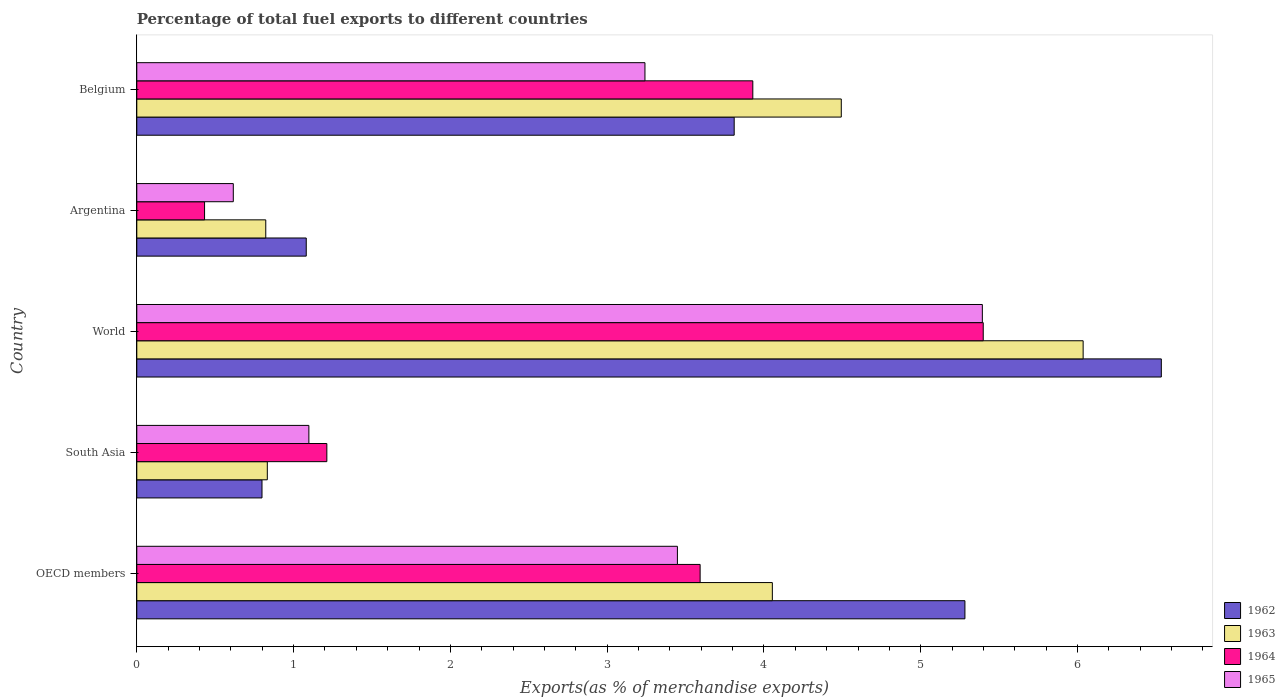Are the number of bars on each tick of the Y-axis equal?
Provide a succinct answer. Yes. How many bars are there on the 4th tick from the top?
Make the answer very short. 4. What is the label of the 2nd group of bars from the top?
Keep it short and to the point. Argentina. What is the percentage of exports to different countries in 1964 in Argentina?
Provide a short and direct response. 0.43. Across all countries, what is the maximum percentage of exports to different countries in 1962?
Your answer should be very brief. 6.53. Across all countries, what is the minimum percentage of exports to different countries in 1964?
Provide a succinct answer. 0.43. In which country was the percentage of exports to different countries in 1962 minimum?
Your response must be concise. South Asia. What is the total percentage of exports to different countries in 1964 in the graph?
Offer a terse response. 14.57. What is the difference between the percentage of exports to different countries in 1962 in Belgium and that in OECD members?
Provide a succinct answer. -1.47. What is the difference between the percentage of exports to different countries in 1964 in OECD members and the percentage of exports to different countries in 1965 in Argentina?
Offer a terse response. 2.98. What is the average percentage of exports to different countries in 1963 per country?
Give a very brief answer. 3.25. What is the difference between the percentage of exports to different countries in 1963 and percentage of exports to different countries in 1965 in Belgium?
Your answer should be compact. 1.25. What is the ratio of the percentage of exports to different countries in 1964 in Belgium to that in OECD members?
Your answer should be very brief. 1.09. Is the percentage of exports to different countries in 1963 in Belgium less than that in South Asia?
Your answer should be compact. No. What is the difference between the highest and the second highest percentage of exports to different countries in 1963?
Your answer should be very brief. 1.54. What is the difference between the highest and the lowest percentage of exports to different countries in 1962?
Offer a very short reply. 5.74. Is it the case that in every country, the sum of the percentage of exports to different countries in 1965 and percentage of exports to different countries in 1963 is greater than the sum of percentage of exports to different countries in 1964 and percentage of exports to different countries in 1962?
Offer a very short reply. No. What does the 2nd bar from the top in Argentina represents?
Ensure brevity in your answer.  1964. Are all the bars in the graph horizontal?
Offer a very short reply. Yes. Are the values on the major ticks of X-axis written in scientific E-notation?
Provide a short and direct response. No. Does the graph contain any zero values?
Your response must be concise. No. Does the graph contain grids?
Your answer should be compact. No. Where does the legend appear in the graph?
Give a very brief answer. Bottom right. How many legend labels are there?
Provide a short and direct response. 4. What is the title of the graph?
Your response must be concise. Percentage of total fuel exports to different countries. Does "1968" appear as one of the legend labels in the graph?
Offer a very short reply. No. What is the label or title of the X-axis?
Your response must be concise. Exports(as % of merchandise exports). What is the label or title of the Y-axis?
Offer a very short reply. Country. What is the Exports(as % of merchandise exports) of 1962 in OECD members?
Your answer should be very brief. 5.28. What is the Exports(as % of merchandise exports) of 1963 in OECD members?
Offer a terse response. 4.05. What is the Exports(as % of merchandise exports) in 1964 in OECD members?
Make the answer very short. 3.59. What is the Exports(as % of merchandise exports) in 1965 in OECD members?
Provide a succinct answer. 3.45. What is the Exports(as % of merchandise exports) in 1962 in South Asia?
Offer a very short reply. 0.8. What is the Exports(as % of merchandise exports) in 1963 in South Asia?
Make the answer very short. 0.83. What is the Exports(as % of merchandise exports) of 1964 in South Asia?
Make the answer very short. 1.21. What is the Exports(as % of merchandise exports) of 1965 in South Asia?
Your answer should be compact. 1.1. What is the Exports(as % of merchandise exports) of 1962 in World?
Offer a terse response. 6.53. What is the Exports(as % of merchandise exports) of 1963 in World?
Your answer should be very brief. 6.04. What is the Exports(as % of merchandise exports) of 1964 in World?
Your response must be concise. 5.4. What is the Exports(as % of merchandise exports) in 1965 in World?
Offer a very short reply. 5.39. What is the Exports(as % of merchandise exports) of 1962 in Argentina?
Provide a short and direct response. 1.08. What is the Exports(as % of merchandise exports) of 1963 in Argentina?
Provide a short and direct response. 0.82. What is the Exports(as % of merchandise exports) in 1964 in Argentina?
Ensure brevity in your answer.  0.43. What is the Exports(as % of merchandise exports) of 1965 in Argentina?
Offer a very short reply. 0.62. What is the Exports(as % of merchandise exports) of 1962 in Belgium?
Provide a short and direct response. 3.81. What is the Exports(as % of merchandise exports) of 1963 in Belgium?
Offer a terse response. 4.49. What is the Exports(as % of merchandise exports) in 1964 in Belgium?
Your answer should be very brief. 3.93. What is the Exports(as % of merchandise exports) of 1965 in Belgium?
Provide a succinct answer. 3.24. Across all countries, what is the maximum Exports(as % of merchandise exports) of 1962?
Ensure brevity in your answer.  6.53. Across all countries, what is the maximum Exports(as % of merchandise exports) of 1963?
Give a very brief answer. 6.04. Across all countries, what is the maximum Exports(as % of merchandise exports) of 1964?
Your answer should be compact. 5.4. Across all countries, what is the maximum Exports(as % of merchandise exports) of 1965?
Make the answer very short. 5.39. Across all countries, what is the minimum Exports(as % of merchandise exports) of 1962?
Make the answer very short. 0.8. Across all countries, what is the minimum Exports(as % of merchandise exports) in 1963?
Make the answer very short. 0.82. Across all countries, what is the minimum Exports(as % of merchandise exports) in 1964?
Make the answer very short. 0.43. Across all countries, what is the minimum Exports(as % of merchandise exports) of 1965?
Your answer should be very brief. 0.62. What is the total Exports(as % of merchandise exports) of 1962 in the graph?
Offer a very short reply. 17.51. What is the total Exports(as % of merchandise exports) in 1963 in the graph?
Keep it short and to the point. 16.24. What is the total Exports(as % of merchandise exports) of 1964 in the graph?
Offer a terse response. 14.57. What is the total Exports(as % of merchandise exports) of 1965 in the graph?
Keep it short and to the point. 13.8. What is the difference between the Exports(as % of merchandise exports) of 1962 in OECD members and that in South Asia?
Keep it short and to the point. 4.48. What is the difference between the Exports(as % of merchandise exports) in 1963 in OECD members and that in South Asia?
Provide a short and direct response. 3.22. What is the difference between the Exports(as % of merchandise exports) of 1964 in OECD members and that in South Asia?
Make the answer very short. 2.38. What is the difference between the Exports(as % of merchandise exports) in 1965 in OECD members and that in South Asia?
Offer a terse response. 2.35. What is the difference between the Exports(as % of merchandise exports) in 1962 in OECD members and that in World?
Provide a short and direct response. -1.25. What is the difference between the Exports(as % of merchandise exports) of 1963 in OECD members and that in World?
Your answer should be compact. -1.98. What is the difference between the Exports(as % of merchandise exports) in 1964 in OECD members and that in World?
Ensure brevity in your answer.  -1.81. What is the difference between the Exports(as % of merchandise exports) of 1965 in OECD members and that in World?
Provide a short and direct response. -1.94. What is the difference between the Exports(as % of merchandise exports) in 1962 in OECD members and that in Argentina?
Offer a terse response. 4.2. What is the difference between the Exports(as % of merchandise exports) of 1963 in OECD members and that in Argentina?
Offer a very short reply. 3.23. What is the difference between the Exports(as % of merchandise exports) of 1964 in OECD members and that in Argentina?
Make the answer very short. 3.16. What is the difference between the Exports(as % of merchandise exports) of 1965 in OECD members and that in Argentina?
Keep it short and to the point. 2.83. What is the difference between the Exports(as % of merchandise exports) in 1962 in OECD members and that in Belgium?
Keep it short and to the point. 1.47. What is the difference between the Exports(as % of merchandise exports) in 1963 in OECD members and that in Belgium?
Give a very brief answer. -0.44. What is the difference between the Exports(as % of merchandise exports) of 1964 in OECD members and that in Belgium?
Provide a succinct answer. -0.34. What is the difference between the Exports(as % of merchandise exports) of 1965 in OECD members and that in Belgium?
Offer a terse response. 0.21. What is the difference between the Exports(as % of merchandise exports) in 1962 in South Asia and that in World?
Provide a succinct answer. -5.74. What is the difference between the Exports(as % of merchandise exports) of 1963 in South Asia and that in World?
Provide a succinct answer. -5.2. What is the difference between the Exports(as % of merchandise exports) in 1964 in South Asia and that in World?
Provide a short and direct response. -4.19. What is the difference between the Exports(as % of merchandise exports) in 1965 in South Asia and that in World?
Your response must be concise. -4.3. What is the difference between the Exports(as % of merchandise exports) of 1962 in South Asia and that in Argentina?
Give a very brief answer. -0.28. What is the difference between the Exports(as % of merchandise exports) in 1963 in South Asia and that in Argentina?
Make the answer very short. 0.01. What is the difference between the Exports(as % of merchandise exports) of 1964 in South Asia and that in Argentina?
Your response must be concise. 0.78. What is the difference between the Exports(as % of merchandise exports) of 1965 in South Asia and that in Argentina?
Your answer should be compact. 0.48. What is the difference between the Exports(as % of merchandise exports) of 1962 in South Asia and that in Belgium?
Offer a very short reply. -3.01. What is the difference between the Exports(as % of merchandise exports) of 1963 in South Asia and that in Belgium?
Your answer should be compact. -3.66. What is the difference between the Exports(as % of merchandise exports) in 1964 in South Asia and that in Belgium?
Your answer should be very brief. -2.72. What is the difference between the Exports(as % of merchandise exports) of 1965 in South Asia and that in Belgium?
Provide a succinct answer. -2.14. What is the difference between the Exports(as % of merchandise exports) of 1962 in World and that in Argentina?
Offer a terse response. 5.45. What is the difference between the Exports(as % of merchandise exports) in 1963 in World and that in Argentina?
Your response must be concise. 5.21. What is the difference between the Exports(as % of merchandise exports) in 1964 in World and that in Argentina?
Provide a short and direct response. 4.97. What is the difference between the Exports(as % of merchandise exports) in 1965 in World and that in Argentina?
Keep it short and to the point. 4.78. What is the difference between the Exports(as % of merchandise exports) of 1962 in World and that in Belgium?
Give a very brief answer. 2.72. What is the difference between the Exports(as % of merchandise exports) in 1963 in World and that in Belgium?
Offer a very short reply. 1.54. What is the difference between the Exports(as % of merchandise exports) of 1964 in World and that in Belgium?
Your answer should be compact. 1.47. What is the difference between the Exports(as % of merchandise exports) in 1965 in World and that in Belgium?
Make the answer very short. 2.15. What is the difference between the Exports(as % of merchandise exports) of 1962 in Argentina and that in Belgium?
Give a very brief answer. -2.73. What is the difference between the Exports(as % of merchandise exports) in 1963 in Argentina and that in Belgium?
Your response must be concise. -3.67. What is the difference between the Exports(as % of merchandise exports) of 1964 in Argentina and that in Belgium?
Offer a terse response. -3.5. What is the difference between the Exports(as % of merchandise exports) of 1965 in Argentina and that in Belgium?
Offer a very short reply. -2.63. What is the difference between the Exports(as % of merchandise exports) in 1962 in OECD members and the Exports(as % of merchandise exports) in 1963 in South Asia?
Offer a terse response. 4.45. What is the difference between the Exports(as % of merchandise exports) in 1962 in OECD members and the Exports(as % of merchandise exports) in 1964 in South Asia?
Give a very brief answer. 4.07. What is the difference between the Exports(as % of merchandise exports) of 1962 in OECD members and the Exports(as % of merchandise exports) of 1965 in South Asia?
Your answer should be compact. 4.18. What is the difference between the Exports(as % of merchandise exports) of 1963 in OECD members and the Exports(as % of merchandise exports) of 1964 in South Asia?
Offer a very short reply. 2.84. What is the difference between the Exports(as % of merchandise exports) of 1963 in OECD members and the Exports(as % of merchandise exports) of 1965 in South Asia?
Make the answer very short. 2.96. What is the difference between the Exports(as % of merchandise exports) in 1964 in OECD members and the Exports(as % of merchandise exports) in 1965 in South Asia?
Provide a succinct answer. 2.5. What is the difference between the Exports(as % of merchandise exports) of 1962 in OECD members and the Exports(as % of merchandise exports) of 1963 in World?
Offer a very short reply. -0.75. What is the difference between the Exports(as % of merchandise exports) in 1962 in OECD members and the Exports(as % of merchandise exports) in 1964 in World?
Give a very brief answer. -0.12. What is the difference between the Exports(as % of merchandise exports) of 1962 in OECD members and the Exports(as % of merchandise exports) of 1965 in World?
Give a very brief answer. -0.11. What is the difference between the Exports(as % of merchandise exports) of 1963 in OECD members and the Exports(as % of merchandise exports) of 1964 in World?
Offer a very short reply. -1.35. What is the difference between the Exports(as % of merchandise exports) in 1963 in OECD members and the Exports(as % of merchandise exports) in 1965 in World?
Ensure brevity in your answer.  -1.34. What is the difference between the Exports(as % of merchandise exports) in 1964 in OECD members and the Exports(as % of merchandise exports) in 1965 in World?
Keep it short and to the point. -1.8. What is the difference between the Exports(as % of merchandise exports) in 1962 in OECD members and the Exports(as % of merchandise exports) in 1963 in Argentina?
Your answer should be compact. 4.46. What is the difference between the Exports(as % of merchandise exports) in 1962 in OECD members and the Exports(as % of merchandise exports) in 1964 in Argentina?
Offer a very short reply. 4.85. What is the difference between the Exports(as % of merchandise exports) in 1962 in OECD members and the Exports(as % of merchandise exports) in 1965 in Argentina?
Your answer should be compact. 4.67. What is the difference between the Exports(as % of merchandise exports) in 1963 in OECD members and the Exports(as % of merchandise exports) in 1964 in Argentina?
Your answer should be very brief. 3.62. What is the difference between the Exports(as % of merchandise exports) of 1963 in OECD members and the Exports(as % of merchandise exports) of 1965 in Argentina?
Your response must be concise. 3.44. What is the difference between the Exports(as % of merchandise exports) of 1964 in OECD members and the Exports(as % of merchandise exports) of 1965 in Argentina?
Make the answer very short. 2.98. What is the difference between the Exports(as % of merchandise exports) of 1962 in OECD members and the Exports(as % of merchandise exports) of 1963 in Belgium?
Keep it short and to the point. 0.79. What is the difference between the Exports(as % of merchandise exports) in 1962 in OECD members and the Exports(as % of merchandise exports) in 1964 in Belgium?
Your response must be concise. 1.35. What is the difference between the Exports(as % of merchandise exports) of 1962 in OECD members and the Exports(as % of merchandise exports) of 1965 in Belgium?
Ensure brevity in your answer.  2.04. What is the difference between the Exports(as % of merchandise exports) of 1963 in OECD members and the Exports(as % of merchandise exports) of 1964 in Belgium?
Provide a succinct answer. 0.12. What is the difference between the Exports(as % of merchandise exports) in 1963 in OECD members and the Exports(as % of merchandise exports) in 1965 in Belgium?
Your answer should be compact. 0.81. What is the difference between the Exports(as % of merchandise exports) in 1964 in OECD members and the Exports(as % of merchandise exports) in 1965 in Belgium?
Your response must be concise. 0.35. What is the difference between the Exports(as % of merchandise exports) of 1962 in South Asia and the Exports(as % of merchandise exports) of 1963 in World?
Provide a short and direct response. -5.24. What is the difference between the Exports(as % of merchandise exports) of 1962 in South Asia and the Exports(as % of merchandise exports) of 1964 in World?
Ensure brevity in your answer.  -4.6. What is the difference between the Exports(as % of merchandise exports) in 1962 in South Asia and the Exports(as % of merchandise exports) in 1965 in World?
Your response must be concise. -4.59. What is the difference between the Exports(as % of merchandise exports) of 1963 in South Asia and the Exports(as % of merchandise exports) of 1964 in World?
Your answer should be very brief. -4.57. What is the difference between the Exports(as % of merchandise exports) in 1963 in South Asia and the Exports(as % of merchandise exports) in 1965 in World?
Ensure brevity in your answer.  -4.56. What is the difference between the Exports(as % of merchandise exports) in 1964 in South Asia and the Exports(as % of merchandise exports) in 1965 in World?
Give a very brief answer. -4.18. What is the difference between the Exports(as % of merchandise exports) of 1962 in South Asia and the Exports(as % of merchandise exports) of 1963 in Argentina?
Keep it short and to the point. -0.02. What is the difference between the Exports(as % of merchandise exports) in 1962 in South Asia and the Exports(as % of merchandise exports) in 1964 in Argentina?
Give a very brief answer. 0.37. What is the difference between the Exports(as % of merchandise exports) in 1962 in South Asia and the Exports(as % of merchandise exports) in 1965 in Argentina?
Your answer should be compact. 0.18. What is the difference between the Exports(as % of merchandise exports) of 1963 in South Asia and the Exports(as % of merchandise exports) of 1964 in Argentina?
Keep it short and to the point. 0.4. What is the difference between the Exports(as % of merchandise exports) of 1963 in South Asia and the Exports(as % of merchandise exports) of 1965 in Argentina?
Your response must be concise. 0.22. What is the difference between the Exports(as % of merchandise exports) in 1964 in South Asia and the Exports(as % of merchandise exports) in 1965 in Argentina?
Provide a succinct answer. 0.6. What is the difference between the Exports(as % of merchandise exports) in 1962 in South Asia and the Exports(as % of merchandise exports) in 1963 in Belgium?
Your answer should be very brief. -3.69. What is the difference between the Exports(as % of merchandise exports) in 1962 in South Asia and the Exports(as % of merchandise exports) in 1964 in Belgium?
Make the answer very short. -3.13. What is the difference between the Exports(as % of merchandise exports) of 1962 in South Asia and the Exports(as % of merchandise exports) of 1965 in Belgium?
Your answer should be compact. -2.44. What is the difference between the Exports(as % of merchandise exports) in 1963 in South Asia and the Exports(as % of merchandise exports) in 1964 in Belgium?
Give a very brief answer. -3.1. What is the difference between the Exports(as % of merchandise exports) of 1963 in South Asia and the Exports(as % of merchandise exports) of 1965 in Belgium?
Provide a short and direct response. -2.41. What is the difference between the Exports(as % of merchandise exports) of 1964 in South Asia and the Exports(as % of merchandise exports) of 1965 in Belgium?
Offer a very short reply. -2.03. What is the difference between the Exports(as % of merchandise exports) in 1962 in World and the Exports(as % of merchandise exports) in 1963 in Argentina?
Your answer should be very brief. 5.71. What is the difference between the Exports(as % of merchandise exports) in 1962 in World and the Exports(as % of merchandise exports) in 1964 in Argentina?
Ensure brevity in your answer.  6.1. What is the difference between the Exports(as % of merchandise exports) of 1962 in World and the Exports(as % of merchandise exports) of 1965 in Argentina?
Keep it short and to the point. 5.92. What is the difference between the Exports(as % of merchandise exports) of 1963 in World and the Exports(as % of merchandise exports) of 1964 in Argentina?
Your answer should be compact. 5.6. What is the difference between the Exports(as % of merchandise exports) of 1963 in World and the Exports(as % of merchandise exports) of 1965 in Argentina?
Provide a succinct answer. 5.42. What is the difference between the Exports(as % of merchandise exports) in 1964 in World and the Exports(as % of merchandise exports) in 1965 in Argentina?
Make the answer very short. 4.78. What is the difference between the Exports(as % of merchandise exports) of 1962 in World and the Exports(as % of merchandise exports) of 1963 in Belgium?
Your answer should be compact. 2.04. What is the difference between the Exports(as % of merchandise exports) of 1962 in World and the Exports(as % of merchandise exports) of 1964 in Belgium?
Provide a short and direct response. 2.61. What is the difference between the Exports(as % of merchandise exports) in 1962 in World and the Exports(as % of merchandise exports) in 1965 in Belgium?
Offer a very short reply. 3.29. What is the difference between the Exports(as % of merchandise exports) of 1963 in World and the Exports(as % of merchandise exports) of 1964 in Belgium?
Make the answer very short. 2.11. What is the difference between the Exports(as % of merchandise exports) of 1963 in World and the Exports(as % of merchandise exports) of 1965 in Belgium?
Your response must be concise. 2.79. What is the difference between the Exports(as % of merchandise exports) in 1964 in World and the Exports(as % of merchandise exports) in 1965 in Belgium?
Offer a very short reply. 2.16. What is the difference between the Exports(as % of merchandise exports) in 1962 in Argentina and the Exports(as % of merchandise exports) in 1963 in Belgium?
Provide a short and direct response. -3.41. What is the difference between the Exports(as % of merchandise exports) of 1962 in Argentina and the Exports(as % of merchandise exports) of 1964 in Belgium?
Give a very brief answer. -2.85. What is the difference between the Exports(as % of merchandise exports) in 1962 in Argentina and the Exports(as % of merchandise exports) in 1965 in Belgium?
Offer a very short reply. -2.16. What is the difference between the Exports(as % of merchandise exports) of 1963 in Argentina and the Exports(as % of merchandise exports) of 1964 in Belgium?
Offer a terse response. -3.11. What is the difference between the Exports(as % of merchandise exports) in 1963 in Argentina and the Exports(as % of merchandise exports) in 1965 in Belgium?
Give a very brief answer. -2.42. What is the difference between the Exports(as % of merchandise exports) of 1964 in Argentina and the Exports(as % of merchandise exports) of 1965 in Belgium?
Make the answer very short. -2.81. What is the average Exports(as % of merchandise exports) in 1962 per country?
Offer a terse response. 3.5. What is the average Exports(as % of merchandise exports) in 1963 per country?
Offer a very short reply. 3.25. What is the average Exports(as % of merchandise exports) in 1964 per country?
Offer a very short reply. 2.91. What is the average Exports(as % of merchandise exports) of 1965 per country?
Your answer should be compact. 2.76. What is the difference between the Exports(as % of merchandise exports) in 1962 and Exports(as % of merchandise exports) in 1963 in OECD members?
Your response must be concise. 1.23. What is the difference between the Exports(as % of merchandise exports) in 1962 and Exports(as % of merchandise exports) in 1964 in OECD members?
Ensure brevity in your answer.  1.69. What is the difference between the Exports(as % of merchandise exports) of 1962 and Exports(as % of merchandise exports) of 1965 in OECD members?
Your answer should be very brief. 1.83. What is the difference between the Exports(as % of merchandise exports) of 1963 and Exports(as % of merchandise exports) of 1964 in OECD members?
Your response must be concise. 0.46. What is the difference between the Exports(as % of merchandise exports) in 1963 and Exports(as % of merchandise exports) in 1965 in OECD members?
Ensure brevity in your answer.  0.61. What is the difference between the Exports(as % of merchandise exports) in 1964 and Exports(as % of merchandise exports) in 1965 in OECD members?
Ensure brevity in your answer.  0.14. What is the difference between the Exports(as % of merchandise exports) of 1962 and Exports(as % of merchandise exports) of 1963 in South Asia?
Offer a terse response. -0.03. What is the difference between the Exports(as % of merchandise exports) of 1962 and Exports(as % of merchandise exports) of 1964 in South Asia?
Provide a short and direct response. -0.41. What is the difference between the Exports(as % of merchandise exports) in 1962 and Exports(as % of merchandise exports) in 1965 in South Asia?
Your answer should be very brief. -0.3. What is the difference between the Exports(as % of merchandise exports) in 1963 and Exports(as % of merchandise exports) in 1964 in South Asia?
Your answer should be very brief. -0.38. What is the difference between the Exports(as % of merchandise exports) of 1963 and Exports(as % of merchandise exports) of 1965 in South Asia?
Keep it short and to the point. -0.27. What is the difference between the Exports(as % of merchandise exports) of 1964 and Exports(as % of merchandise exports) of 1965 in South Asia?
Give a very brief answer. 0.11. What is the difference between the Exports(as % of merchandise exports) of 1962 and Exports(as % of merchandise exports) of 1963 in World?
Your answer should be compact. 0.5. What is the difference between the Exports(as % of merchandise exports) in 1962 and Exports(as % of merchandise exports) in 1964 in World?
Offer a very short reply. 1.14. What is the difference between the Exports(as % of merchandise exports) in 1962 and Exports(as % of merchandise exports) in 1965 in World?
Give a very brief answer. 1.14. What is the difference between the Exports(as % of merchandise exports) in 1963 and Exports(as % of merchandise exports) in 1964 in World?
Give a very brief answer. 0.64. What is the difference between the Exports(as % of merchandise exports) in 1963 and Exports(as % of merchandise exports) in 1965 in World?
Ensure brevity in your answer.  0.64. What is the difference between the Exports(as % of merchandise exports) in 1964 and Exports(as % of merchandise exports) in 1965 in World?
Your answer should be compact. 0.01. What is the difference between the Exports(as % of merchandise exports) of 1962 and Exports(as % of merchandise exports) of 1963 in Argentina?
Make the answer very short. 0.26. What is the difference between the Exports(as % of merchandise exports) in 1962 and Exports(as % of merchandise exports) in 1964 in Argentina?
Provide a short and direct response. 0.65. What is the difference between the Exports(as % of merchandise exports) in 1962 and Exports(as % of merchandise exports) in 1965 in Argentina?
Your answer should be very brief. 0.47. What is the difference between the Exports(as % of merchandise exports) of 1963 and Exports(as % of merchandise exports) of 1964 in Argentina?
Offer a terse response. 0.39. What is the difference between the Exports(as % of merchandise exports) of 1963 and Exports(as % of merchandise exports) of 1965 in Argentina?
Provide a short and direct response. 0.21. What is the difference between the Exports(as % of merchandise exports) of 1964 and Exports(as % of merchandise exports) of 1965 in Argentina?
Make the answer very short. -0.18. What is the difference between the Exports(as % of merchandise exports) in 1962 and Exports(as % of merchandise exports) in 1963 in Belgium?
Offer a very short reply. -0.68. What is the difference between the Exports(as % of merchandise exports) of 1962 and Exports(as % of merchandise exports) of 1964 in Belgium?
Provide a short and direct response. -0.12. What is the difference between the Exports(as % of merchandise exports) of 1962 and Exports(as % of merchandise exports) of 1965 in Belgium?
Keep it short and to the point. 0.57. What is the difference between the Exports(as % of merchandise exports) in 1963 and Exports(as % of merchandise exports) in 1964 in Belgium?
Keep it short and to the point. 0.56. What is the difference between the Exports(as % of merchandise exports) of 1963 and Exports(as % of merchandise exports) of 1965 in Belgium?
Your answer should be very brief. 1.25. What is the difference between the Exports(as % of merchandise exports) of 1964 and Exports(as % of merchandise exports) of 1965 in Belgium?
Ensure brevity in your answer.  0.69. What is the ratio of the Exports(as % of merchandise exports) of 1962 in OECD members to that in South Asia?
Make the answer very short. 6.61. What is the ratio of the Exports(as % of merchandise exports) in 1963 in OECD members to that in South Asia?
Provide a short and direct response. 4.87. What is the ratio of the Exports(as % of merchandise exports) of 1964 in OECD members to that in South Asia?
Keep it short and to the point. 2.96. What is the ratio of the Exports(as % of merchandise exports) of 1965 in OECD members to that in South Asia?
Your answer should be compact. 3.14. What is the ratio of the Exports(as % of merchandise exports) in 1962 in OECD members to that in World?
Ensure brevity in your answer.  0.81. What is the ratio of the Exports(as % of merchandise exports) of 1963 in OECD members to that in World?
Give a very brief answer. 0.67. What is the ratio of the Exports(as % of merchandise exports) of 1964 in OECD members to that in World?
Offer a terse response. 0.67. What is the ratio of the Exports(as % of merchandise exports) in 1965 in OECD members to that in World?
Give a very brief answer. 0.64. What is the ratio of the Exports(as % of merchandise exports) in 1962 in OECD members to that in Argentina?
Your answer should be compact. 4.89. What is the ratio of the Exports(as % of merchandise exports) in 1963 in OECD members to that in Argentina?
Keep it short and to the point. 4.93. What is the ratio of the Exports(as % of merchandise exports) of 1964 in OECD members to that in Argentina?
Provide a short and direct response. 8.31. What is the ratio of the Exports(as % of merchandise exports) of 1965 in OECD members to that in Argentina?
Ensure brevity in your answer.  5.6. What is the ratio of the Exports(as % of merchandise exports) of 1962 in OECD members to that in Belgium?
Ensure brevity in your answer.  1.39. What is the ratio of the Exports(as % of merchandise exports) of 1963 in OECD members to that in Belgium?
Your answer should be very brief. 0.9. What is the ratio of the Exports(as % of merchandise exports) of 1964 in OECD members to that in Belgium?
Offer a terse response. 0.91. What is the ratio of the Exports(as % of merchandise exports) in 1965 in OECD members to that in Belgium?
Provide a short and direct response. 1.06. What is the ratio of the Exports(as % of merchandise exports) of 1962 in South Asia to that in World?
Your response must be concise. 0.12. What is the ratio of the Exports(as % of merchandise exports) of 1963 in South Asia to that in World?
Your answer should be very brief. 0.14. What is the ratio of the Exports(as % of merchandise exports) of 1964 in South Asia to that in World?
Your answer should be very brief. 0.22. What is the ratio of the Exports(as % of merchandise exports) of 1965 in South Asia to that in World?
Provide a short and direct response. 0.2. What is the ratio of the Exports(as % of merchandise exports) in 1962 in South Asia to that in Argentina?
Your answer should be very brief. 0.74. What is the ratio of the Exports(as % of merchandise exports) in 1963 in South Asia to that in Argentina?
Ensure brevity in your answer.  1.01. What is the ratio of the Exports(as % of merchandise exports) of 1964 in South Asia to that in Argentina?
Provide a succinct answer. 2.8. What is the ratio of the Exports(as % of merchandise exports) of 1965 in South Asia to that in Argentina?
Give a very brief answer. 1.78. What is the ratio of the Exports(as % of merchandise exports) of 1962 in South Asia to that in Belgium?
Your response must be concise. 0.21. What is the ratio of the Exports(as % of merchandise exports) of 1963 in South Asia to that in Belgium?
Give a very brief answer. 0.19. What is the ratio of the Exports(as % of merchandise exports) in 1964 in South Asia to that in Belgium?
Provide a short and direct response. 0.31. What is the ratio of the Exports(as % of merchandise exports) of 1965 in South Asia to that in Belgium?
Offer a terse response. 0.34. What is the ratio of the Exports(as % of merchandise exports) of 1962 in World to that in Argentina?
Provide a short and direct response. 6.05. What is the ratio of the Exports(as % of merchandise exports) of 1963 in World to that in Argentina?
Offer a very short reply. 7.34. What is the ratio of the Exports(as % of merchandise exports) of 1964 in World to that in Argentina?
Ensure brevity in your answer.  12.49. What is the ratio of the Exports(as % of merchandise exports) in 1965 in World to that in Argentina?
Ensure brevity in your answer.  8.76. What is the ratio of the Exports(as % of merchandise exports) in 1962 in World to that in Belgium?
Your answer should be compact. 1.72. What is the ratio of the Exports(as % of merchandise exports) in 1963 in World to that in Belgium?
Your answer should be very brief. 1.34. What is the ratio of the Exports(as % of merchandise exports) in 1964 in World to that in Belgium?
Keep it short and to the point. 1.37. What is the ratio of the Exports(as % of merchandise exports) of 1965 in World to that in Belgium?
Your answer should be very brief. 1.66. What is the ratio of the Exports(as % of merchandise exports) in 1962 in Argentina to that in Belgium?
Keep it short and to the point. 0.28. What is the ratio of the Exports(as % of merchandise exports) of 1963 in Argentina to that in Belgium?
Keep it short and to the point. 0.18. What is the ratio of the Exports(as % of merchandise exports) in 1964 in Argentina to that in Belgium?
Your answer should be very brief. 0.11. What is the ratio of the Exports(as % of merchandise exports) in 1965 in Argentina to that in Belgium?
Offer a terse response. 0.19. What is the difference between the highest and the second highest Exports(as % of merchandise exports) of 1962?
Provide a succinct answer. 1.25. What is the difference between the highest and the second highest Exports(as % of merchandise exports) in 1963?
Keep it short and to the point. 1.54. What is the difference between the highest and the second highest Exports(as % of merchandise exports) of 1964?
Give a very brief answer. 1.47. What is the difference between the highest and the second highest Exports(as % of merchandise exports) of 1965?
Your answer should be very brief. 1.94. What is the difference between the highest and the lowest Exports(as % of merchandise exports) of 1962?
Your response must be concise. 5.74. What is the difference between the highest and the lowest Exports(as % of merchandise exports) of 1963?
Make the answer very short. 5.21. What is the difference between the highest and the lowest Exports(as % of merchandise exports) in 1964?
Your answer should be compact. 4.97. What is the difference between the highest and the lowest Exports(as % of merchandise exports) of 1965?
Keep it short and to the point. 4.78. 